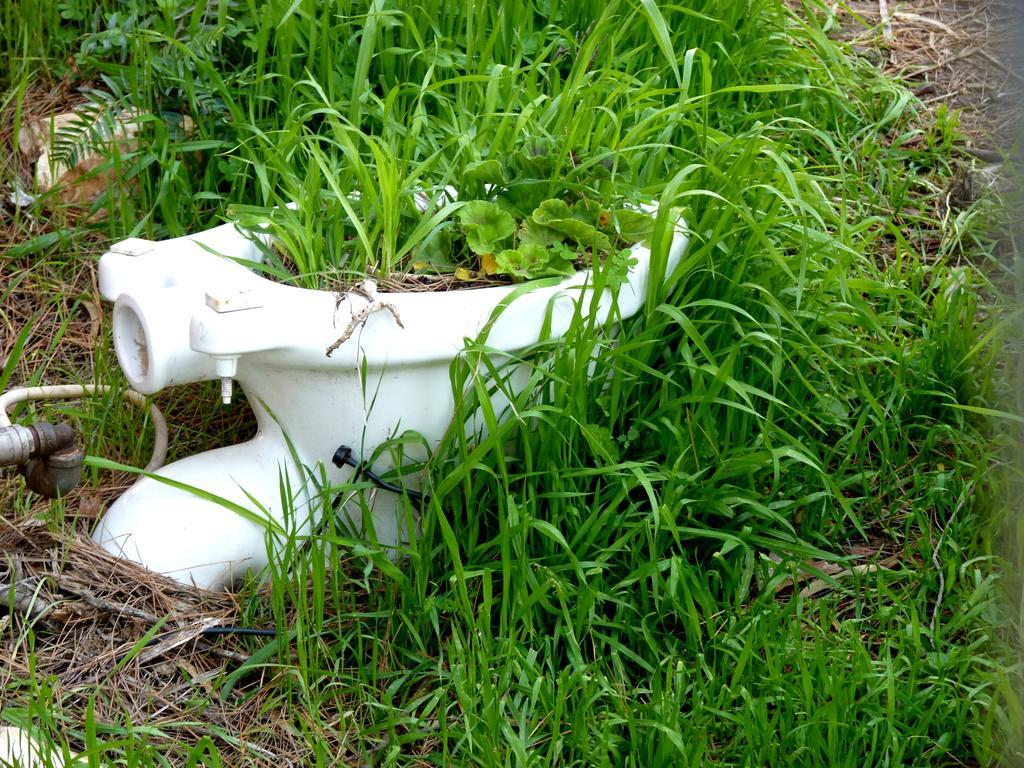In one or two sentences, can you explain what this image depicts? In the picture we can see a toilet seat which is white in color placed near the grass surface and on it also we can see some grass is grown. 